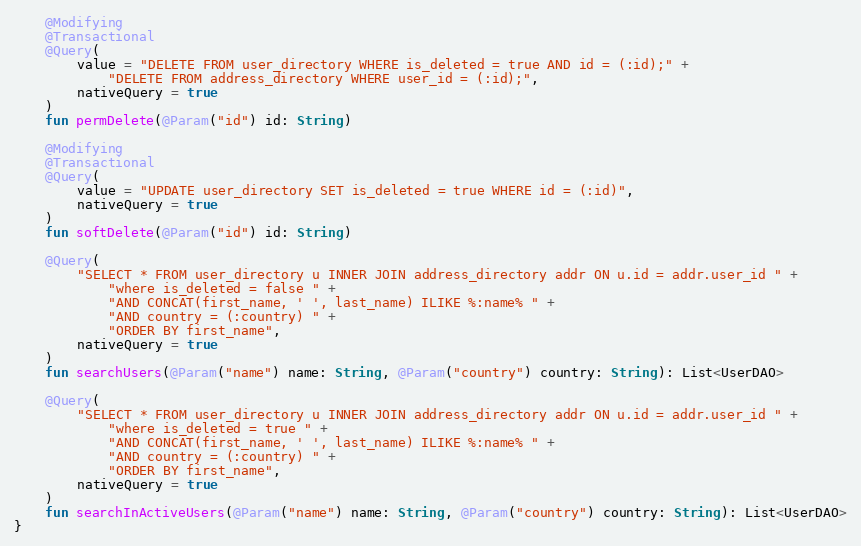Convert code to text. <code><loc_0><loc_0><loc_500><loc_500><_Kotlin_>
    @Modifying
    @Transactional
    @Query(
        value = "DELETE FROM user_directory WHERE is_deleted = true AND id = (:id);" +
            "DELETE FROM address_directory WHERE user_id = (:id);",
        nativeQuery = true
    )
    fun permDelete(@Param("id") id: String)

    @Modifying
    @Transactional
    @Query(
        value = "UPDATE user_directory SET is_deleted = true WHERE id = (:id)",
        nativeQuery = true
    )
    fun softDelete(@Param("id") id: String)

    @Query(
        "SELECT * FROM user_directory u INNER JOIN address_directory addr ON u.id = addr.user_id " +
            "where is_deleted = false " +
            "AND CONCAT(first_name, ' ', last_name) ILIKE %:name% " +
            "AND country = (:country) " +
            "ORDER BY first_name",
        nativeQuery = true
    )
    fun searchUsers(@Param("name") name: String, @Param("country") country: String): List<UserDAO>

    @Query(
        "SELECT * FROM user_directory u INNER JOIN address_directory addr ON u.id = addr.user_id " +
            "where is_deleted = true " +
            "AND CONCAT(first_name, ' ', last_name) ILIKE %:name% " +
            "AND country = (:country) " +
            "ORDER BY first_name",
        nativeQuery = true
    )
    fun searchInActiveUsers(@Param("name") name: String, @Param("country") country: String): List<UserDAO>
}</code> 